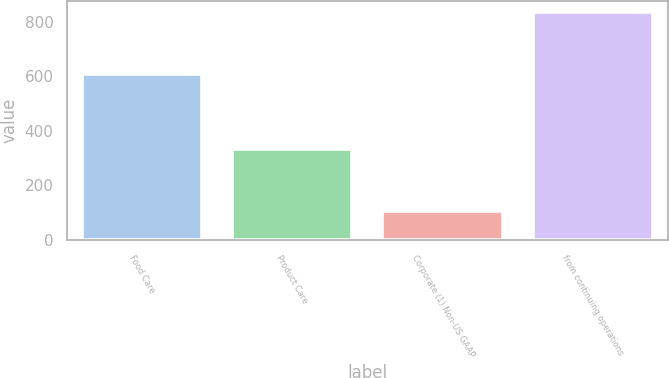Convert chart. <chart><loc_0><loc_0><loc_500><loc_500><bar_chart><fcel>Food Care<fcel>Product Care<fcel>Corporate (1) Non-US GAAP<fcel>from continuing operations<nl><fcel>608.3<fcel>332.3<fcel>107.3<fcel>833.3<nl></chart> 